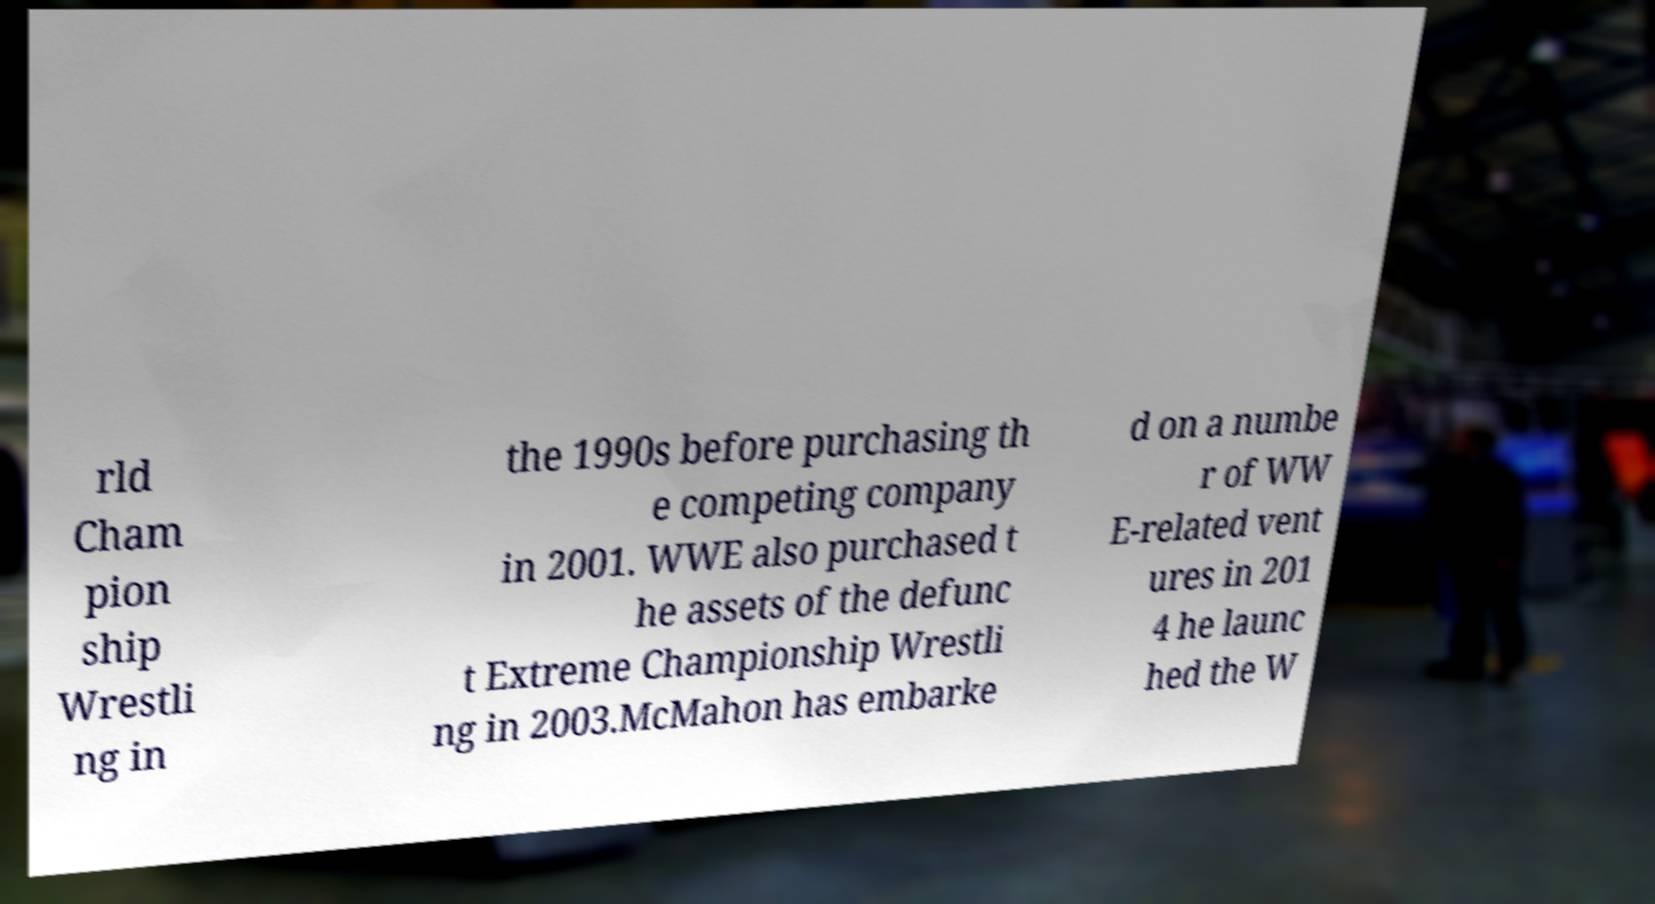Please identify and transcribe the text found in this image. rld Cham pion ship Wrestli ng in the 1990s before purchasing th e competing company in 2001. WWE also purchased t he assets of the defunc t Extreme Championship Wrestli ng in 2003.McMahon has embarke d on a numbe r of WW E-related vent ures in 201 4 he launc hed the W 